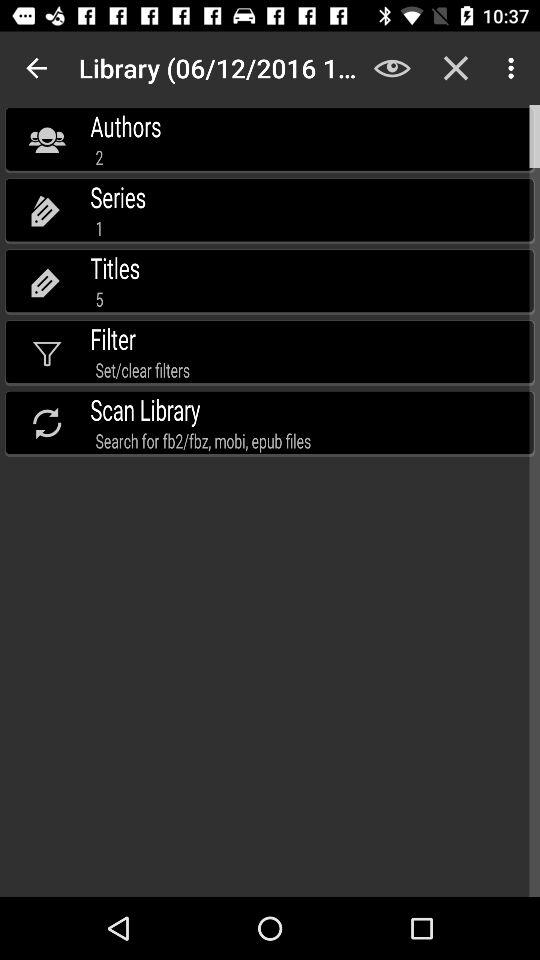What is the total number of titles? The total number of titles is 5. 